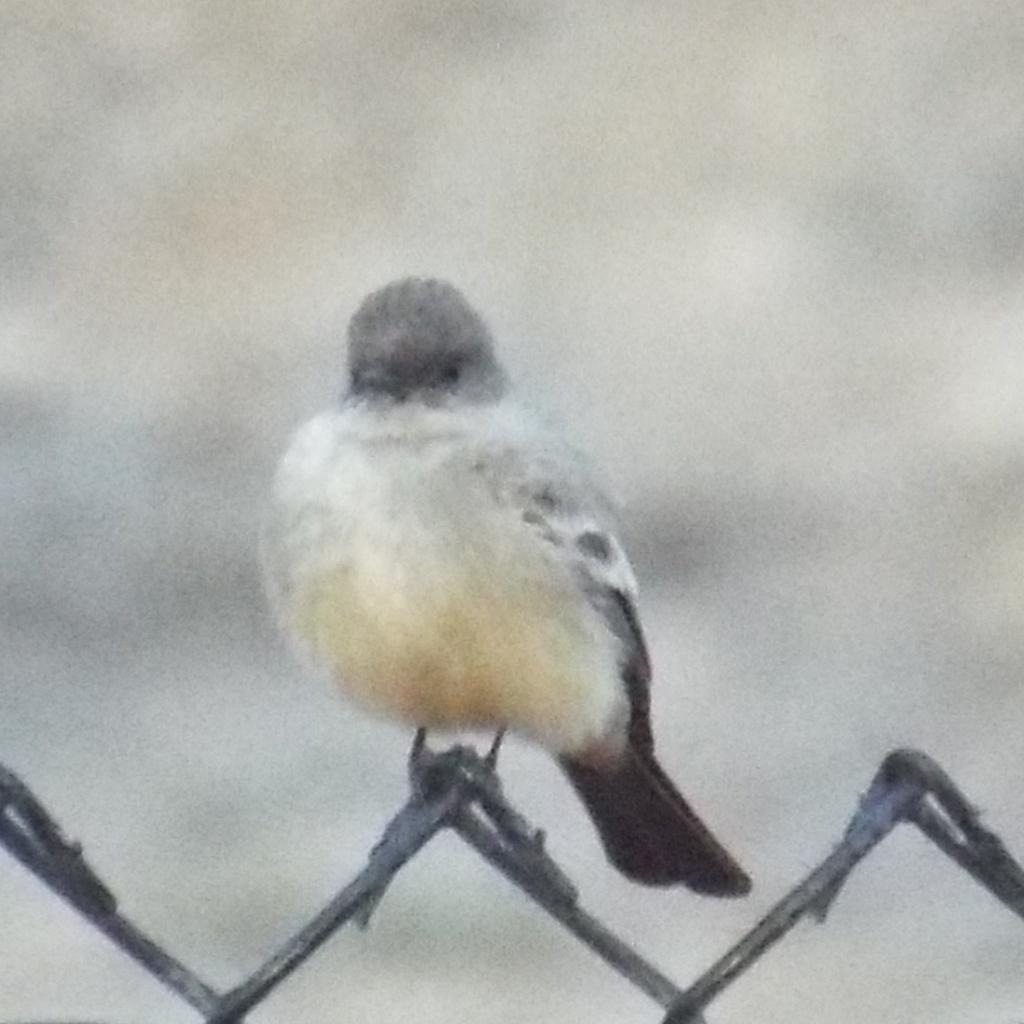Where was the image taken? The image was taken outdoors. Can you describe the background of the image? The background of the image is slightly blurred. What is the main subject of the image? There is a bird in the middle of the image. What is the bird standing on? The bird is on a mesh. Where is the mesh located in the image? There is a mesh at the bottom of the image. What type of twig is the bird using to distribute morning greetings in the image? There is no twig or morning greetings present in the image; it only features a bird on a mesh. 